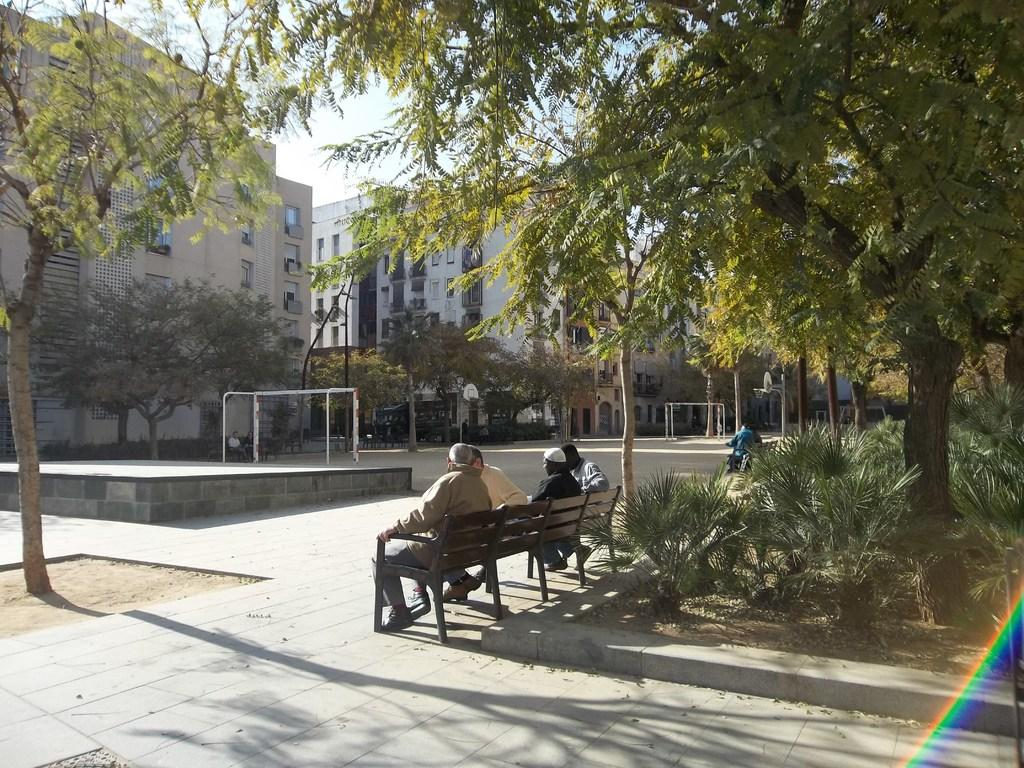How many people are sitting on the bench in the image? There are four people sitting on the bench in the image. Where is the bench located in relation to the tree? The bench is under a tree in the image. What can be seen in the background of the image? There are two apartments in the background of the image. What type of area is the scene located near? The scene is beside a playground. What historical event is being commemorated by the people sitting on the bench? There is no indication of a historical event being commemorated in the image; it simply shows four people sitting on a bench. 